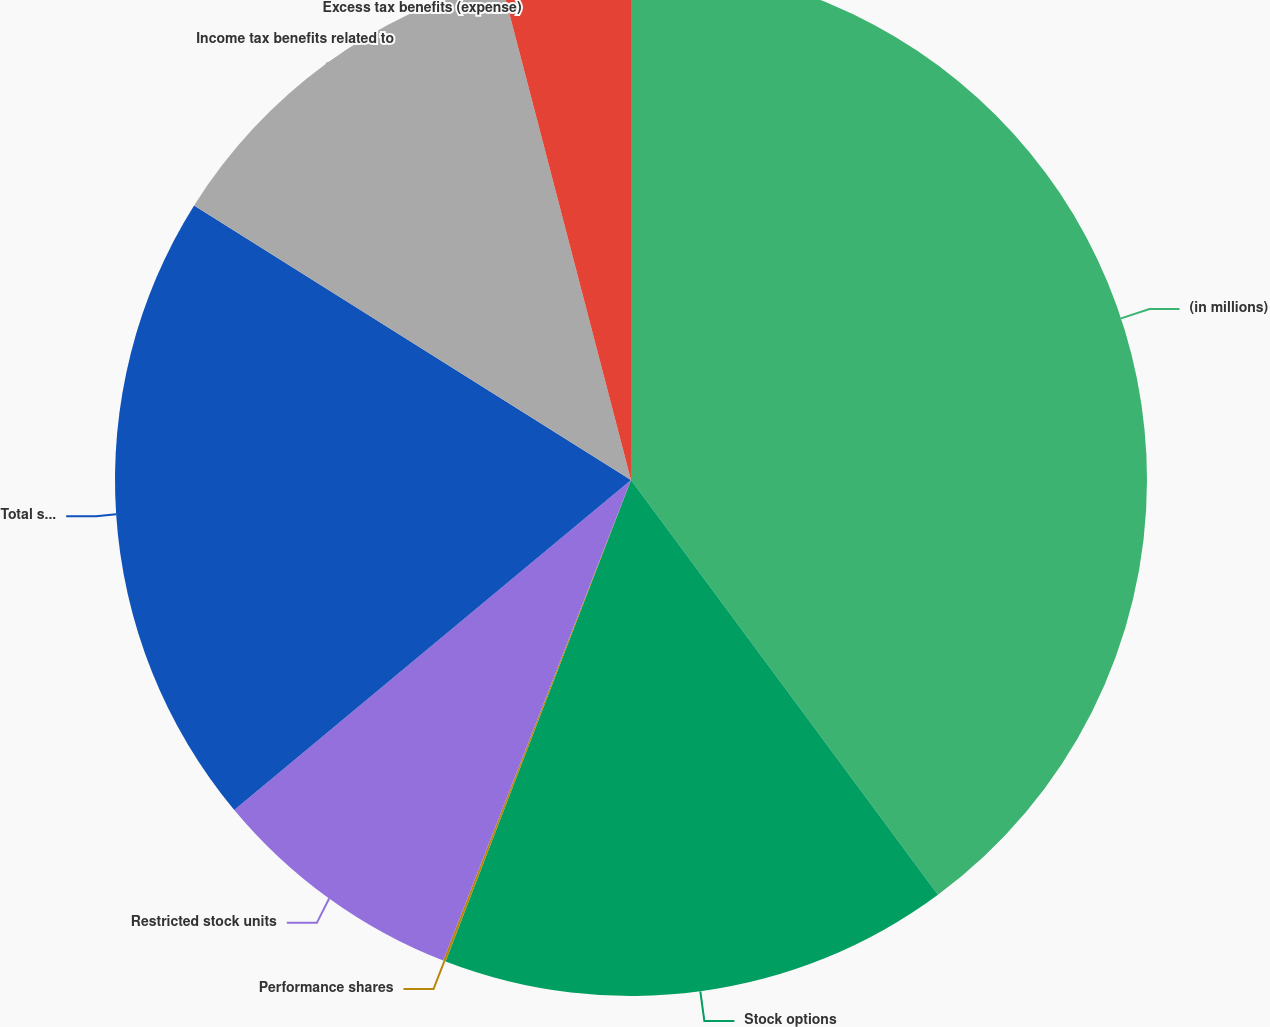<chart> <loc_0><loc_0><loc_500><loc_500><pie_chart><fcel>(in millions)<fcel>Stock options<fcel>Performance shares<fcel>Restricted stock units<fcel>Total stock-based compensation<fcel>Income tax benefits related to<fcel>Excess tax benefits (expense)<nl><fcel>39.86%<fcel>15.99%<fcel>0.08%<fcel>8.03%<fcel>19.97%<fcel>12.01%<fcel>4.06%<nl></chart> 